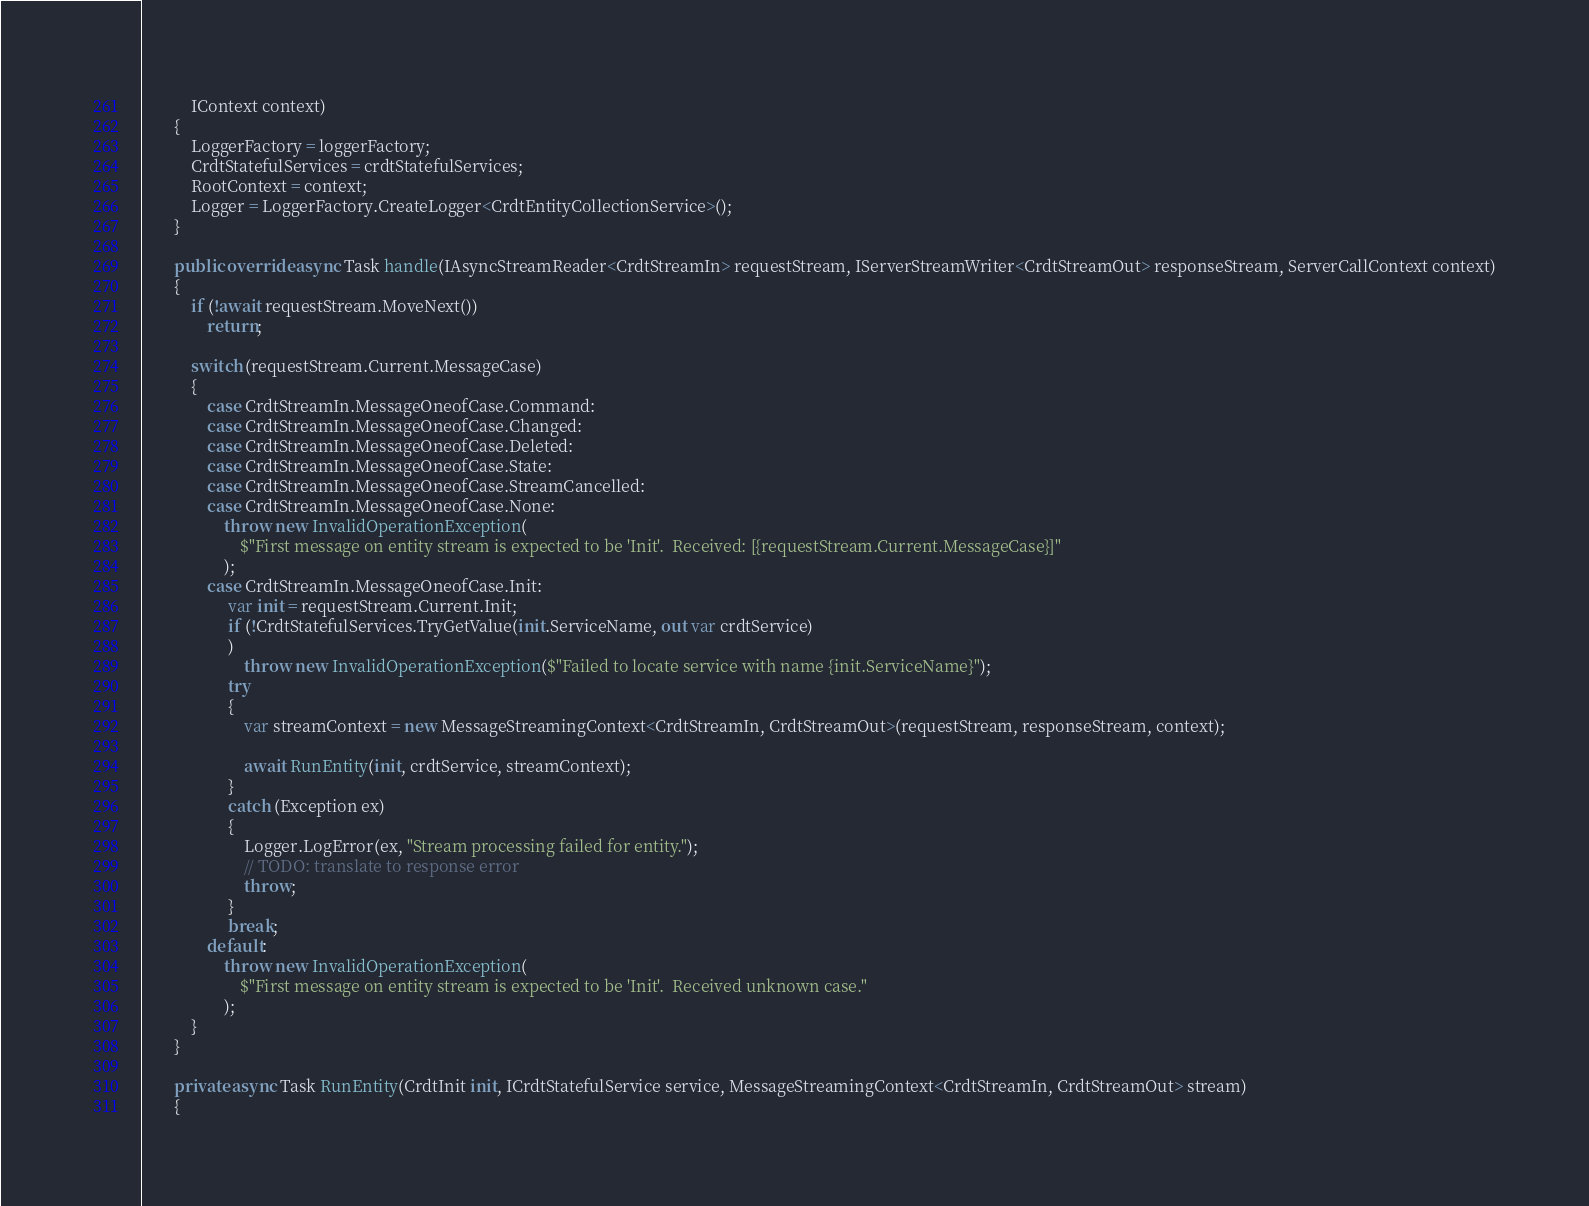Convert code to text. <code><loc_0><loc_0><loc_500><loc_500><_C#_>            IContext context)
        {
            LoggerFactory = loggerFactory;
            CrdtStatefulServices = crdtStatefulServices;
            RootContext = context;
            Logger = LoggerFactory.CreateLogger<CrdtEntityCollectionService>();
        }

        public override async Task handle(IAsyncStreamReader<CrdtStreamIn> requestStream, IServerStreamWriter<CrdtStreamOut> responseStream, ServerCallContext context)
        {
            if (!await requestStream.MoveNext())
                return;

            switch (requestStream.Current.MessageCase)
            {
                case CrdtStreamIn.MessageOneofCase.Command:
                case CrdtStreamIn.MessageOneofCase.Changed:
                case CrdtStreamIn.MessageOneofCase.Deleted:
                case CrdtStreamIn.MessageOneofCase.State:
                case CrdtStreamIn.MessageOneofCase.StreamCancelled:
                case CrdtStreamIn.MessageOneofCase.None:
                    throw new InvalidOperationException(
                        $"First message on entity stream is expected to be 'Init'.  Received: [{requestStream.Current.MessageCase}]"
                    );
                case CrdtStreamIn.MessageOneofCase.Init:
                     var init = requestStream.Current.Init;
                     if (!CrdtStatefulServices.TryGetValue(init.ServiceName, out var crdtService)
                     )
                         throw new InvalidOperationException($"Failed to locate service with name {init.ServiceName}");
                     try
                     {
                         var streamContext = new MessageStreamingContext<CrdtStreamIn, CrdtStreamOut>(requestStream, responseStream, context);

                         await RunEntity(init, crdtService, streamContext);
                     }
                     catch (Exception ex)
                     {
                         Logger.LogError(ex, "Stream processing failed for entity.");
                         // TODO: translate to response error
                         throw;
                     }
                     break;
                default:
                    throw new InvalidOperationException(
                        $"First message on entity stream is expected to be 'Init'.  Received unknown case."
                    );
            }
        }

        private async Task RunEntity(CrdtInit init, ICrdtStatefulService service, MessageStreamingContext<CrdtStreamIn, CrdtStreamOut> stream)
        {</code> 